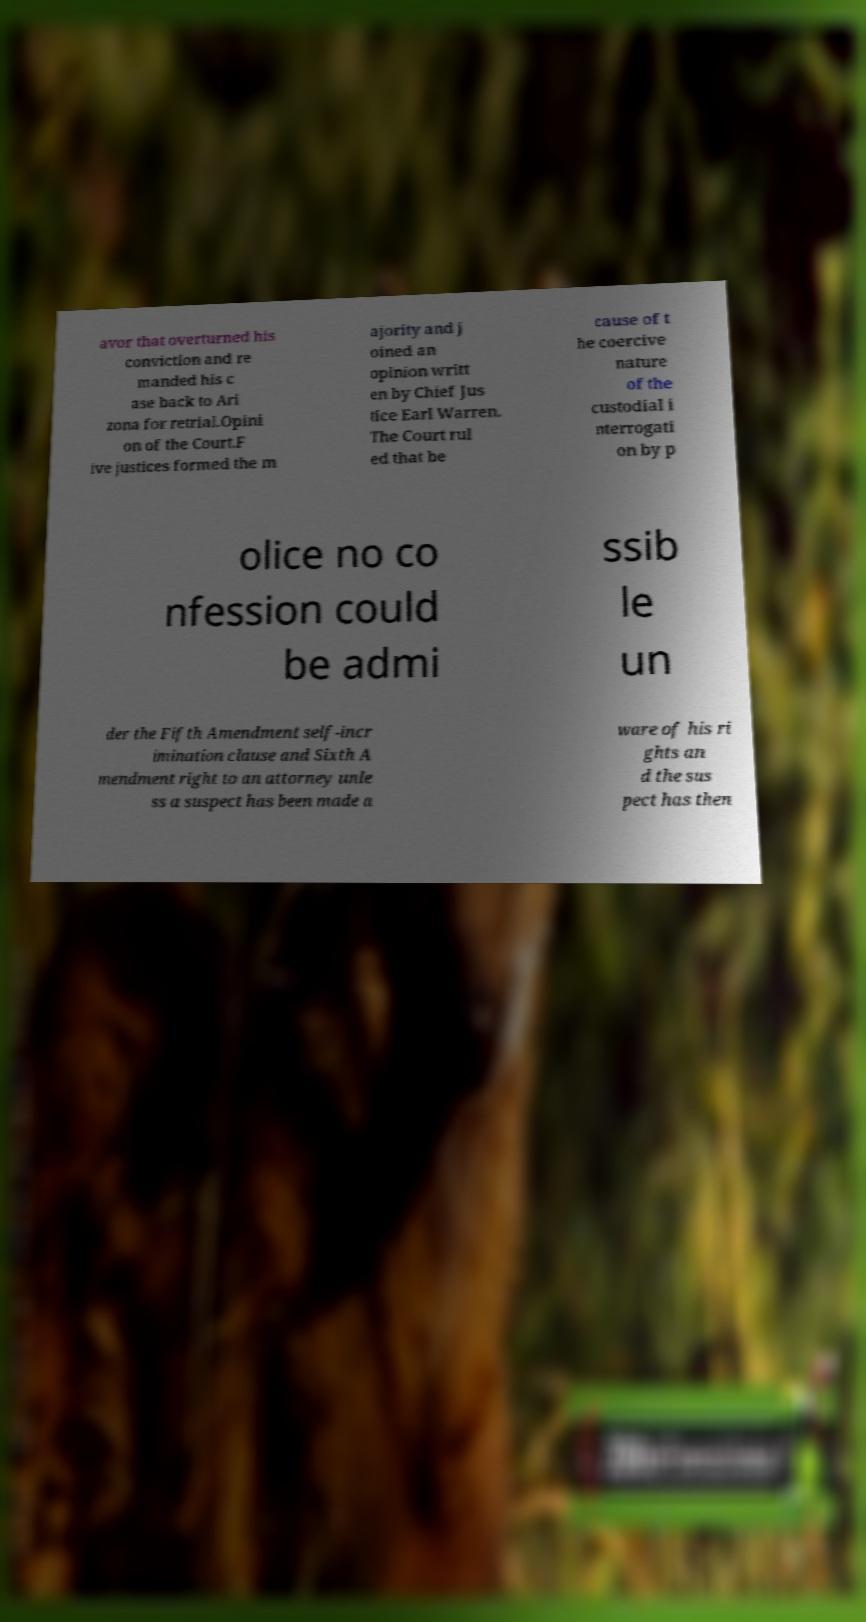Please identify and transcribe the text found in this image. avor that overturned his conviction and re manded his c ase back to Ari zona for retrial.Opini on of the Court.F ive justices formed the m ajority and j oined an opinion writt en by Chief Jus tice Earl Warren. The Court rul ed that be cause of t he coercive nature of the custodial i nterrogati on by p olice no co nfession could be admi ssib le un der the Fifth Amendment self-incr imination clause and Sixth A mendment right to an attorney unle ss a suspect has been made a ware of his ri ghts an d the sus pect has then 